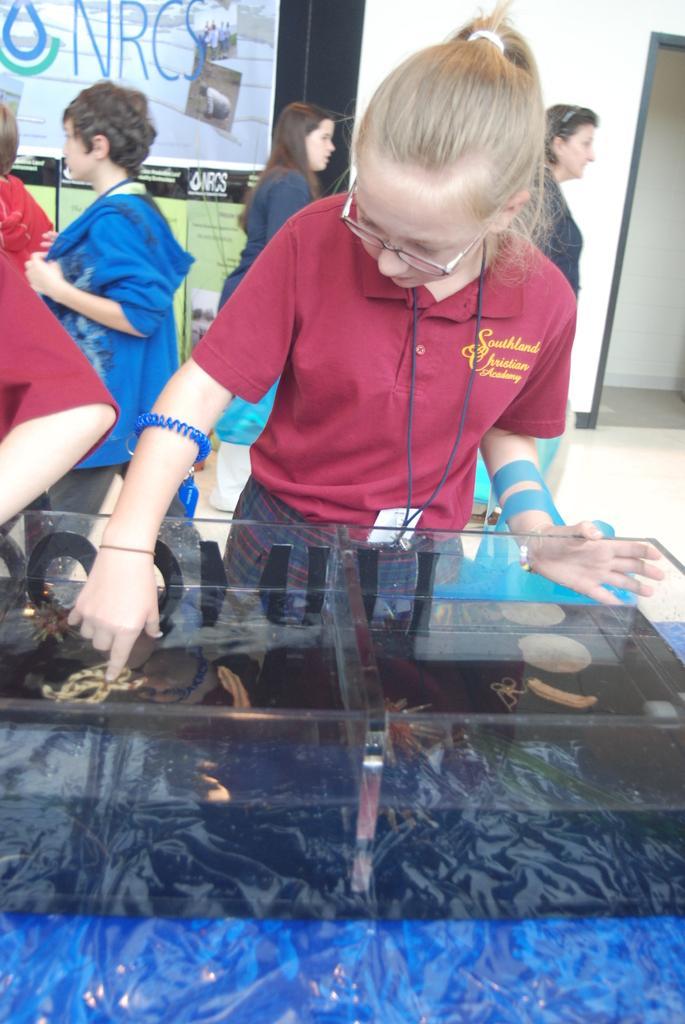Describe this image in one or two sentences. As we can see in the image there are few people here and there, banners, wall and aquarium. In aquarium there are fishes and water. 